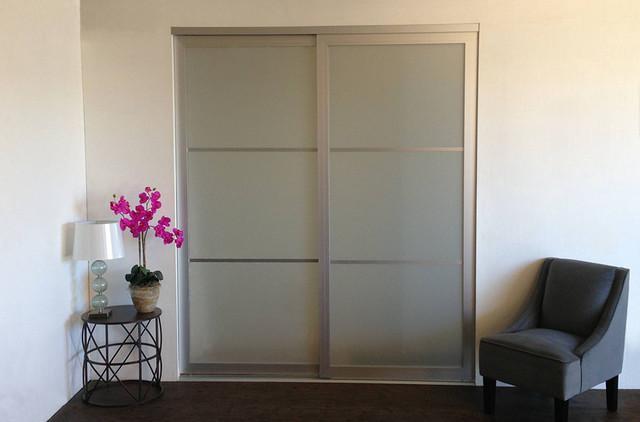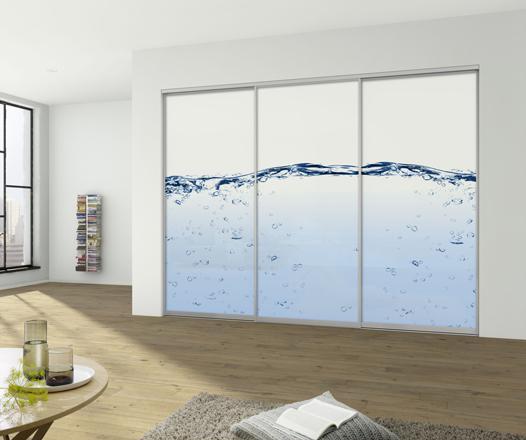The first image is the image on the left, the second image is the image on the right. Assess this claim about the two images: "A cushioned chair sits outside a door in the image on the left.". Correct or not? Answer yes or no. Yes. The first image is the image on the left, the second image is the image on the right. For the images shown, is this caption "One closet's doors has a photographic image design." true? Answer yes or no. Yes. 